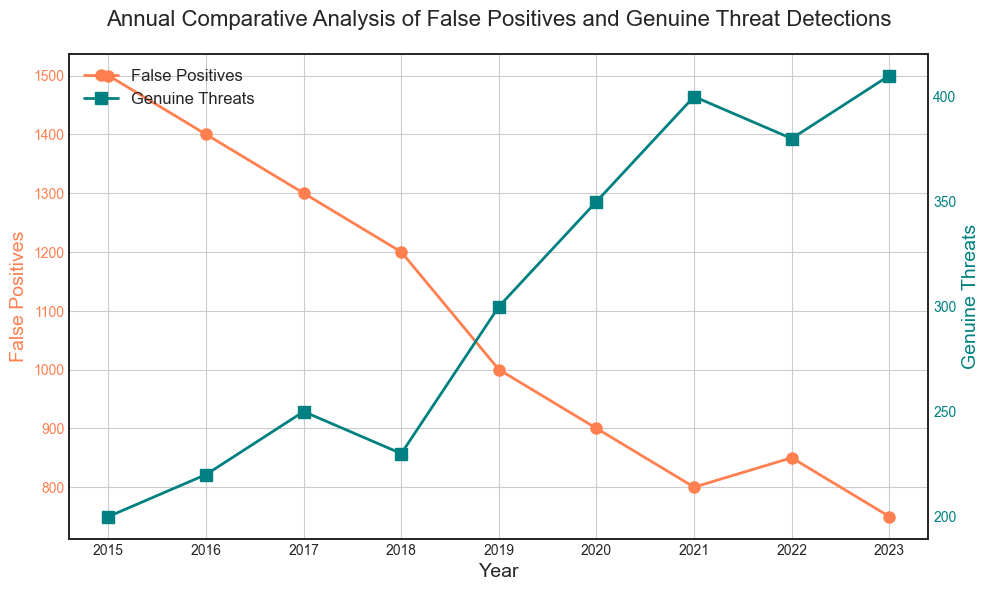What's the average number of Genuine Threats detected from 2015 to 2023? To calculate the average, sum up all the numbers of Genuine Threats from 2015 to 2023 and then divide by the total number of years. The numbers are 200, 220, 250, 230, 300, 350, 400, 380, and 410. The sum is 2740. Divide this by 9 (the number of years): 2740 / 9 = 304.44.
Answer: 304.44 In which year was the difference between False Positives and Genuine Threats the smallest? The difference for each year is calculated as: 2015 (1500 - 200 = 1300), 2016 (1400 - 220 = 1180), 2017 (1300 - 250 = 1050), 2018 (1200 - 230 = 970), 2019 (1000 - 300 = 700), 2020 (900 - 350 = 550), 2021 (800 - 400 = 400), 2022 (850 - 380 = 470), 2023 (750 - 410 = 340). The smallest difference is in 2023.
Answer: 2023 Which year had the highest number of False Positives? From the visual plot, identify the highest point on the red line representing False Positives. The highest point occurs in the year 2015 with 1500 False Positives.
Answer: 2015 Over the period from 2015 to 2023, how many times did the number of False Positives decrease from the previous year? By examining the plot line of False Positives (red), we see decreases from 2015 to 2016, 2016 to 2017, 2017 to 2018, 2018 to 2019, 2019 to 2020, 2020 to 2021, 2021 to 2022, and 2022 to 2023. Thus, decreases occurred 8 times.
Answer: 8 What is the total number of Genuine Threats detected over the last three years (2021, 2022, 2023)? Sum up the number of Genuine Threats for the years 2021 (400), 2022 (380), and 2023 (410). The sum is 400 + 380 + 410 = 1190.
Answer: 1190 Compare the trend of False Positives and Genuine Threats from 2015 to 2023. Which trend is increasing and which is decreasing? The plot shows that the red line (False Positives) is generally decreasing over time, whereas the teal line (Genuine Threats) is generally increasing over the same period.
Answer: False Positives decreasing, Genuine Threats increasing During which year did the number of Genuine Threats detected exceed 350 for the first time? By following the teal line, observe each point above 350. The first occurrence is in the year 2020.
Answer: 2020 What was the percentage decrease in False Positives from 2015 to 2023? Calculate the decrease in False Positives from 1500 in 2015 to 750 in 2023. The decrease is 1500 - 750 = 750. The percentage decrease is (750 / 1500) * 100% = 50%.
Answer: 50% Is there any year where the number of Genuine Threats decreased compared to the previous year? By examining the teal line, we see that the number of Genuine Threats decreased from 2017 to 2018 (250 to 230) and from 2021 to 2022 (400 to 380).
Answer: Yes, 2018 and 2022 